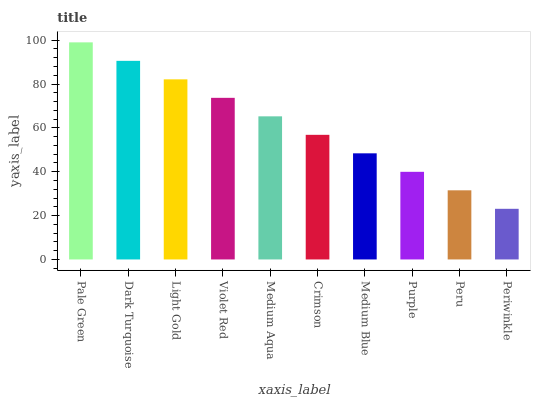Is Periwinkle the minimum?
Answer yes or no. Yes. Is Pale Green the maximum?
Answer yes or no. Yes. Is Dark Turquoise the minimum?
Answer yes or no. No. Is Dark Turquoise the maximum?
Answer yes or no. No. Is Pale Green greater than Dark Turquoise?
Answer yes or no. Yes. Is Dark Turquoise less than Pale Green?
Answer yes or no. Yes. Is Dark Turquoise greater than Pale Green?
Answer yes or no. No. Is Pale Green less than Dark Turquoise?
Answer yes or no. No. Is Medium Aqua the high median?
Answer yes or no. Yes. Is Crimson the low median?
Answer yes or no. Yes. Is Medium Blue the high median?
Answer yes or no. No. Is Dark Turquoise the low median?
Answer yes or no. No. 